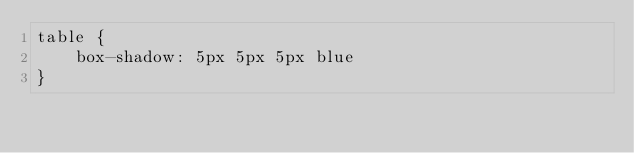Convert code to text. <code><loc_0><loc_0><loc_500><loc_500><_CSS_>table {
    box-shadow: 5px 5px 5px blue
}</code> 